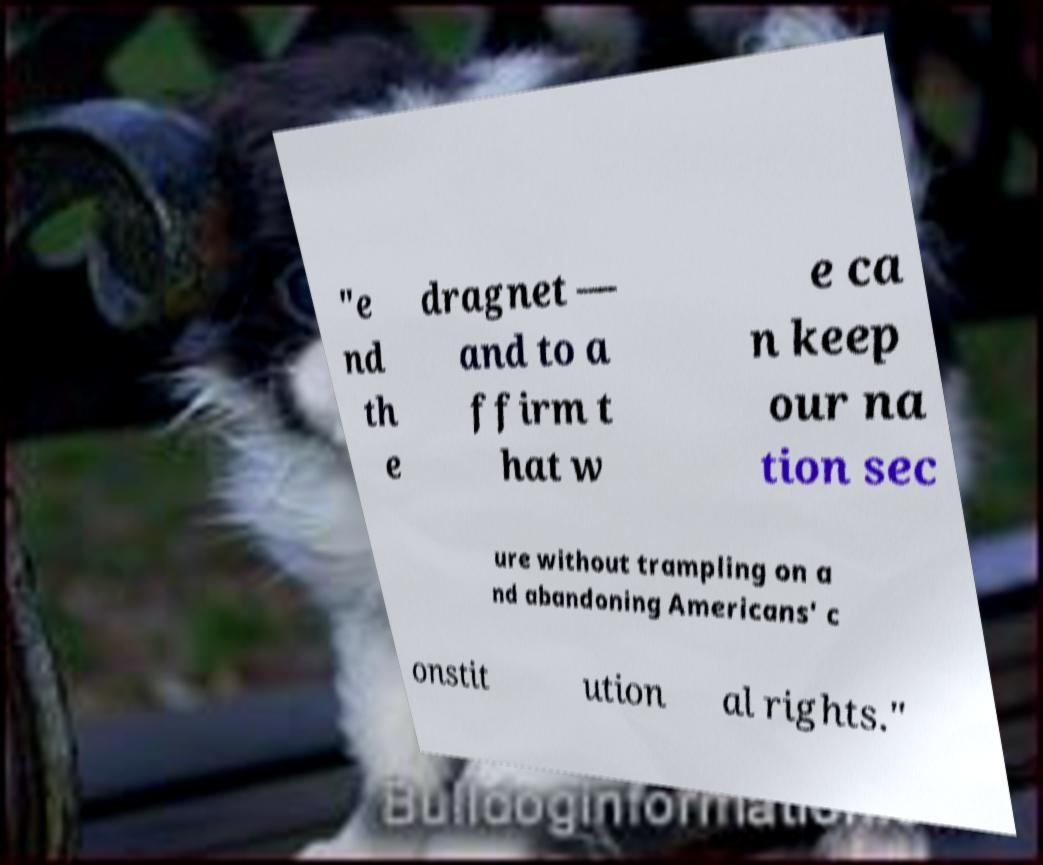There's text embedded in this image that I need extracted. Can you transcribe it verbatim? "e nd th e dragnet — and to a ffirm t hat w e ca n keep our na tion sec ure without trampling on a nd abandoning Americans' c onstit ution al rights." 